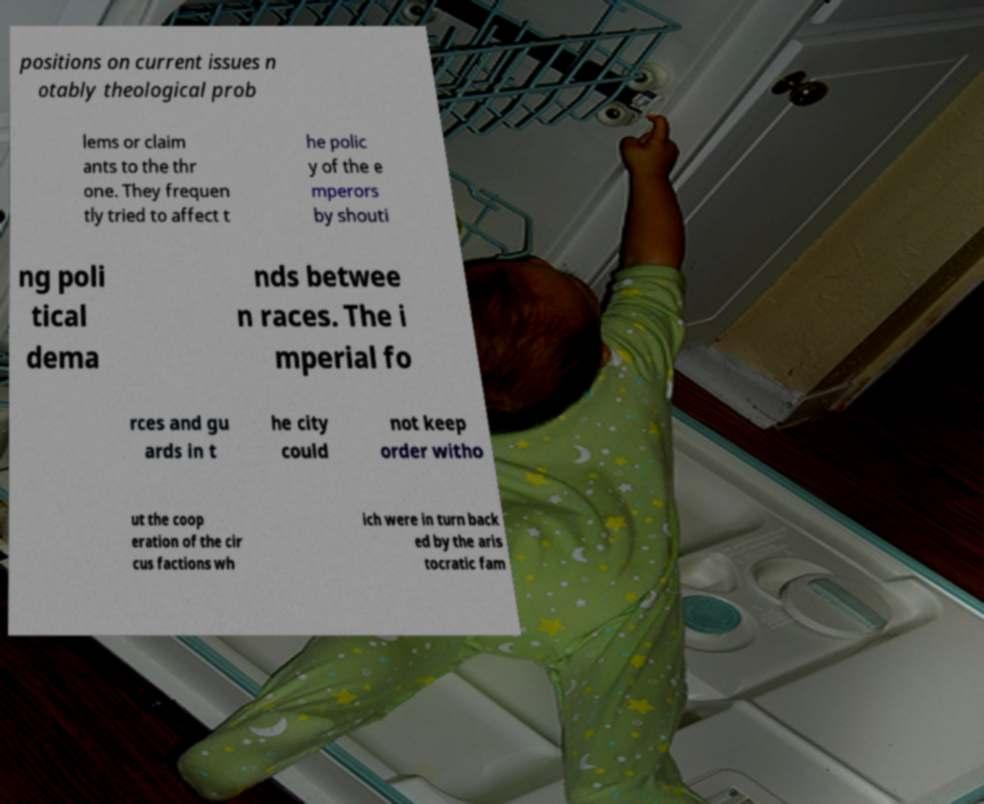Please identify and transcribe the text found in this image. positions on current issues n otably theological prob lems or claim ants to the thr one. They frequen tly tried to affect t he polic y of the e mperors by shouti ng poli tical dema nds betwee n races. The i mperial fo rces and gu ards in t he city could not keep order witho ut the coop eration of the cir cus factions wh ich were in turn back ed by the aris tocratic fam 